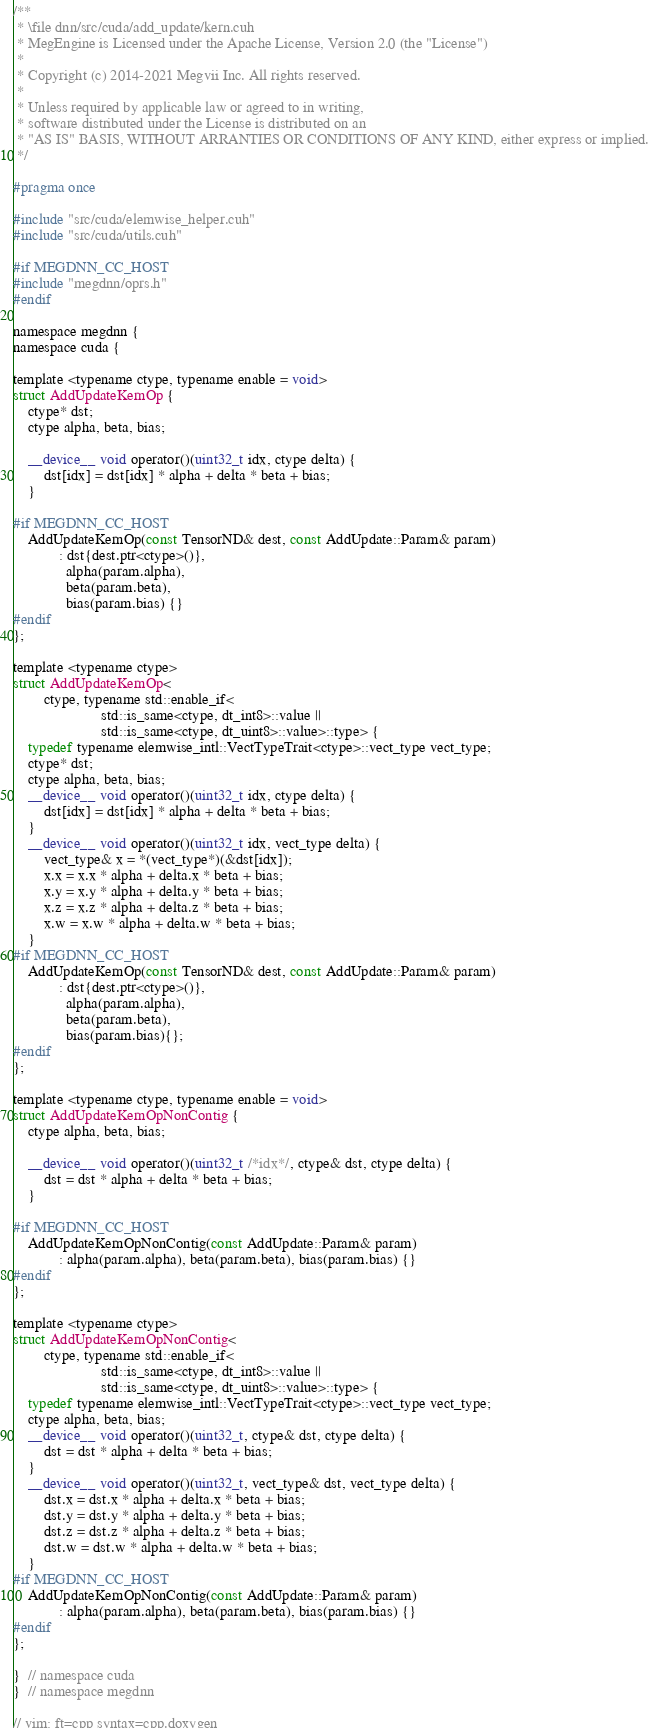Convert code to text. <code><loc_0><loc_0><loc_500><loc_500><_Cuda_>/**
 * \file dnn/src/cuda/add_update/kern.cuh
 * MegEngine is Licensed under the Apache License, Version 2.0 (the "License")
 *
 * Copyright (c) 2014-2021 Megvii Inc. All rights reserved.
 *
 * Unless required by applicable law or agreed to in writing,
 * software distributed under the License is distributed on an
 * "AS IS" BASIS, WITHOUT ARRANTIES OR CONDITIONS OF ANY KIND, either express or implied.
 */

#pragma once

#include "src/cuda/elemwise_helper.cuh"
#include "src/cuda/utils.cuh"

#if MEGDNN_CC_HOST
#include "megdnn/oprs.h"
#endif

namespace megdnn {
namespace cuda {

template <typename ctype, typename enable = void>
struct AddUpdateKernOp {
    ctype* dst;
    ctype alpha, beta, bias;

    __device__ void operator()(uint32_t idx, ctype delta) {
        dst[idx] = dst[idx] * alpha + delta * beta + bias;
    }

#if MEGDNN_CC_HOST
    AddUpdateKernOp(const TensorND& dest, const AddUpdate::Param& param)
            : dst{dest.ptr<ctype>()},
              alpha(param.alpha),
              beta(param.beta),
              bias(param.bias) {}
#endif
};

template <typename ctype>
struct AddUpdateKernOp<
        ctype, typename std::enable_if<
                       std::is_same<ctype, dt_int8>::value ||
                       std::is_same<ctype, dt_uint8>::value>::type> {
    typedef typename elemwise_intl::VectTypeTrait<ctype>::vect_type vect_type;
    ctype* dst;
    ctype alpha, beta, bias;
    __device__ void operator()(uint32_t idx, ctype delta) {
        dst[idx] = dst[idx] * alpha + delta * beta + bias;
    }
    __device__ void operator()(uint32_t idx, vect_type delta) {
        vect_type& x = *(vect_type*)(&dst[idx]);
        x.x = x.x * alpha + delta.x * beta + bias;
        x.y = x.y * alpha + delta.y * beta + bias;
        x.z = x.z * alpha + delta.z * beta + bias;
        x.w = x.w * alpha + delta.w * beta + bias;
    }
#if MEGDNN_CC_HOST
    AddUpdateKernOp(const TensorND& dest, const AddUpdate::Param& param)
            : dst{dest.ptr<ctype>()},
              alpha(param.alpha),
              beta(param.beta),
              bias(param.bias){};
#endif
};

template <typename ctype, typename enable = void>
struct AddUpdateKernOpNonContig {
    ctype alpha, beta, bias;

    __device__ void operator()(uint32_t /*idx*/, ctype& dst, ctype delta) {
        dst = dst * alpha + delta * beta + bias;
    }

#if MEGDNN_CC_HOST
    AddUpdateKernOpNonContig(const AddUpdate::Param& param)
            : alpha(param.alpha), beta(param.beta), bias(param.bias) {}
#endif
};

template <typename ctype>
struct AddUpdateKernOpNonContig<
        ctype, typename std::enable_if<
                       std::is_same<ctype, dt_int8>::value ||
                       std::is_same<ctype, dt_uint8>::value>::type> {
    typedef typename elemwise_intl::VectTypeTrait<ctype>::vect_type vect_type;
    ctype alpha, beta, bias;
    __device__ void operator()(uint32_t, ctype& dst, ctype delta) {
        dst = dst * alpha + delta * beta + bias;
    }
    __device__ void operator()(uint32_t, vect_type& dst, vect_type delta) {
        dst.x = dst.x * alpha + delta.x * beta + bias;
        dst.y = dst.y * alpha + delta.y * beta + bias;
        dst.z = dst.z * alpha + delta.z * beta + bias;
        dst.w = dst.w * alpha + delta.w * beta + bias;
    }
#if MEGDNN_CC_HOST
    AddUpdateKernOpNonContig(const AddUpdate::Param& param)
            : alpha(param.alpha), beta(param.beta), bias(param.bias) {}
#endif
};

}  // namespace cuda
}  // namespace megdnn

// vim: ft=cpp syntax=cpp.doxygen
</code> 